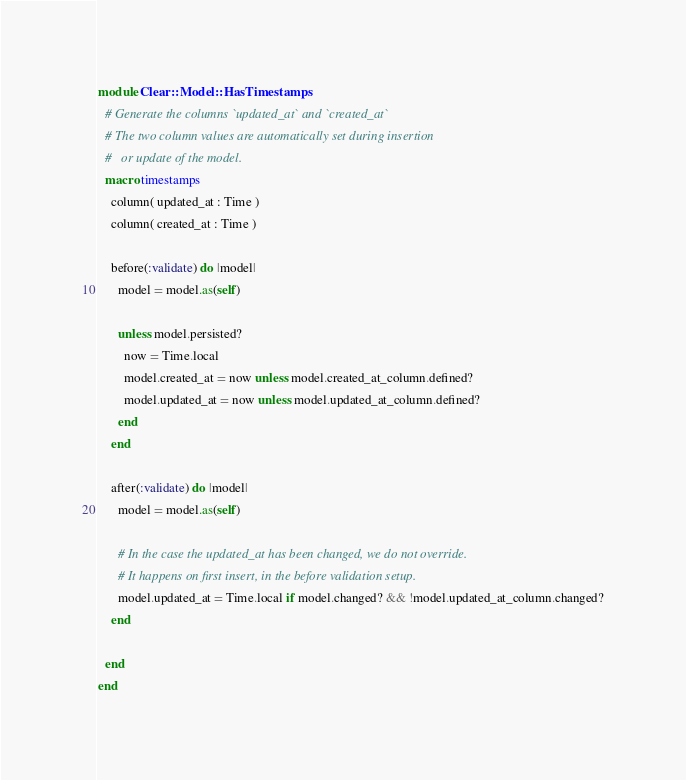<code> <loc_0><loc_0><loc_500><loc_500><_Crystal_>module Clear::Model::HasTimestamps
  # Generate the columns `updated_at` and `created_at`
  # The two column values are automatically set during insertion
  #   or update of the model.
  macro timestamps
    column( updated_at : Time )
    column( created_at : Time )

    before(:validate) do |model|
      model = model.as(self)

      unless model.persisted?
        now = Time.local
        model.created_at = now unless model.created_at_column.defined?
        model.updated_at = now unless model.updated_at_column.defined?
      end
    end

    after(:validate) do |model|
      model = model.as(self)

      # In the case the updated_at has been changed, we do not override.
      # It happens on first insert, in the before validation setup.
      model.updated_at = Time.local if model.changed? && !model.updated_at_column.changed?
    end

  end
end
</code> 